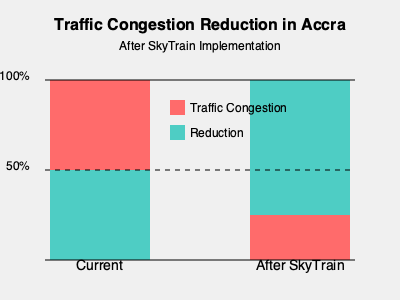Based on the infographic, what is the expected percentage reduction in traffic congestion in Accra after the implementation of the SkyTrain project? How might this impact the daily lives of Ghanaian citizens? To determine the expected percentage reduction in traffic congestion:

1. Observe the "Current" situation:
   - The red bar represents 100% of current traffic congestion.

2. Examine the "After SkyTrain" situation:
   - The red bar is reduced, and the green bar shows the reduction.

3. Estimate the reduction:
   - The green bar covers approximately 75% of the total height.
   - This indicates a 75% reduction in traffic congestion.

4. Calculate the remaining congestion:
   - 100% - 75% = 25% remaining congestion

5. Impact on daily lives of Ghanaian citizens:
   - Significantly reduced travel times
   - Less stress during commutes
   - Improved air quality due to fewer vehicles on the road
   - Potential economic benefits from increased productivity
   - Enhanced mobility, especially for those without personal vehicles
   - Possible reduction in road accidents
   - Pride in modernized public transportation system

The SkyTrain project promises to dramatically transform urban mobility in Accra, potentially leading to a more efficient, cleaner, and more prosperous city for its citizens.
Answer: 75% reduction; improved commutes, air quality, and urban efficiency 